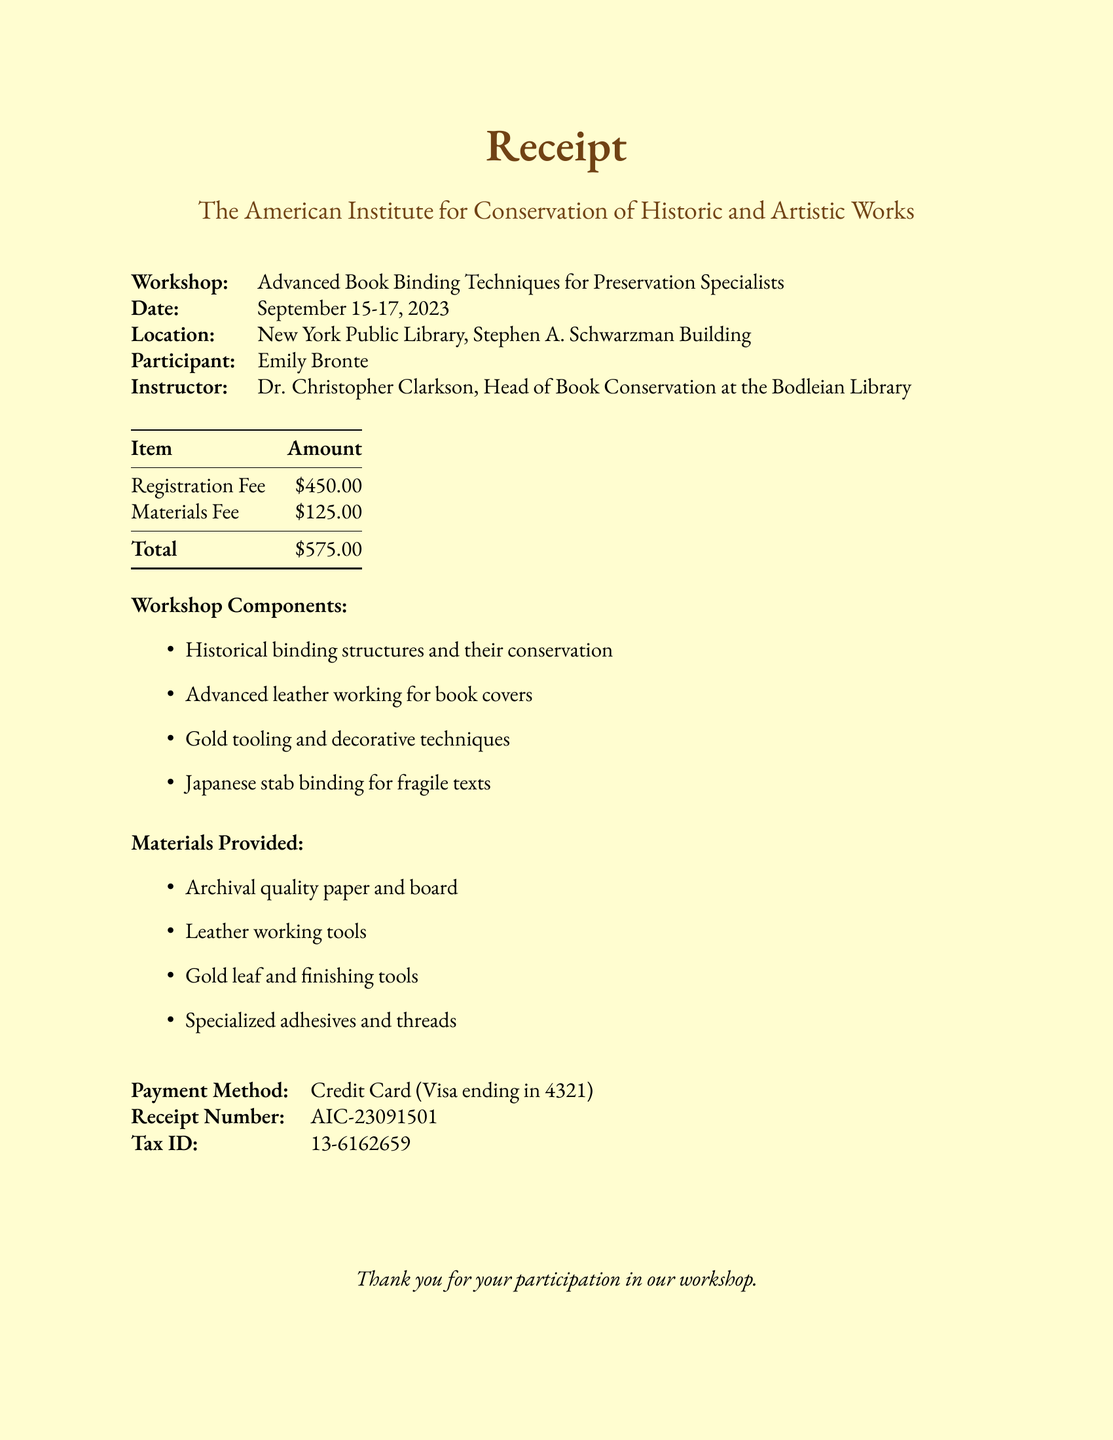What is the name of the workshop? The workshop is titled "Advanced Book Binding Techniques for Preservation Specialists."
Answer: Advanced Book Binding Techniques for Preservation Specialists Who is the instructor? The receipt states that the instructor is Dr. Christopher Clarkson.
Answer: Dr. Christopher Clarkson What are the dates of the workshop? The workshop is scheduled from September 15 to September 17, 2023.
Answer: September 15-17, 2023 What is the registration fee? The document lists the registration fee as $450.00.
Answer: $450.00 How much was the materials fee? The materials fee mentioned in the receipt is $125.00.
Answer: $125.00 What is the total amount due? The total amount is the sum of the registration and materials fees, which equals $575.00.
Answer: $575.00 What types of materials are provided? The materials include archival quality paper and board, leather working tools, gold leaf and finishing tools, and specialized adhesives and threads.
Answer: Archival quality paper and board, leather working tools, gold leaf and finishing tools, specialized adhesives and threads What payment method was used? The payment method used for the registration is a credit card (Visa).
Answer: Credit Card (Visa) What is the receipt number? The document provides receipt number AIC-23091501 for this transaction.
Answer: AIC-23091501 